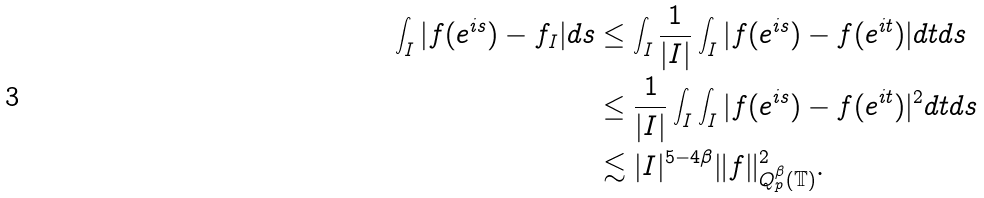Convert formula to latex. <formula><loc_0><loc_0><loc_500><loc_500>\int _ { I } | f ( e ^ { i s } ) - f _ { I } | d s & \leq \int _ { I } \frac { 1 } { | I | } \int _ { I } | f ( e ^ { i s } ) - f ( e ^ { i t } ) | d t d s \\ & \leq \frac { 1 } { | I | } \int _ { I } \int _ { I } | f ( e ^ { i s } ) - f ( e ^ { i t } ) | ^ { 2 } d t d s \\ & \lesssim | I | ^ { 5 - 4 \beta } \| f \| _ { Q _ { p } ^ { \beta } ( \mathbb { T } ) } ^ { 2 } .</formula> 